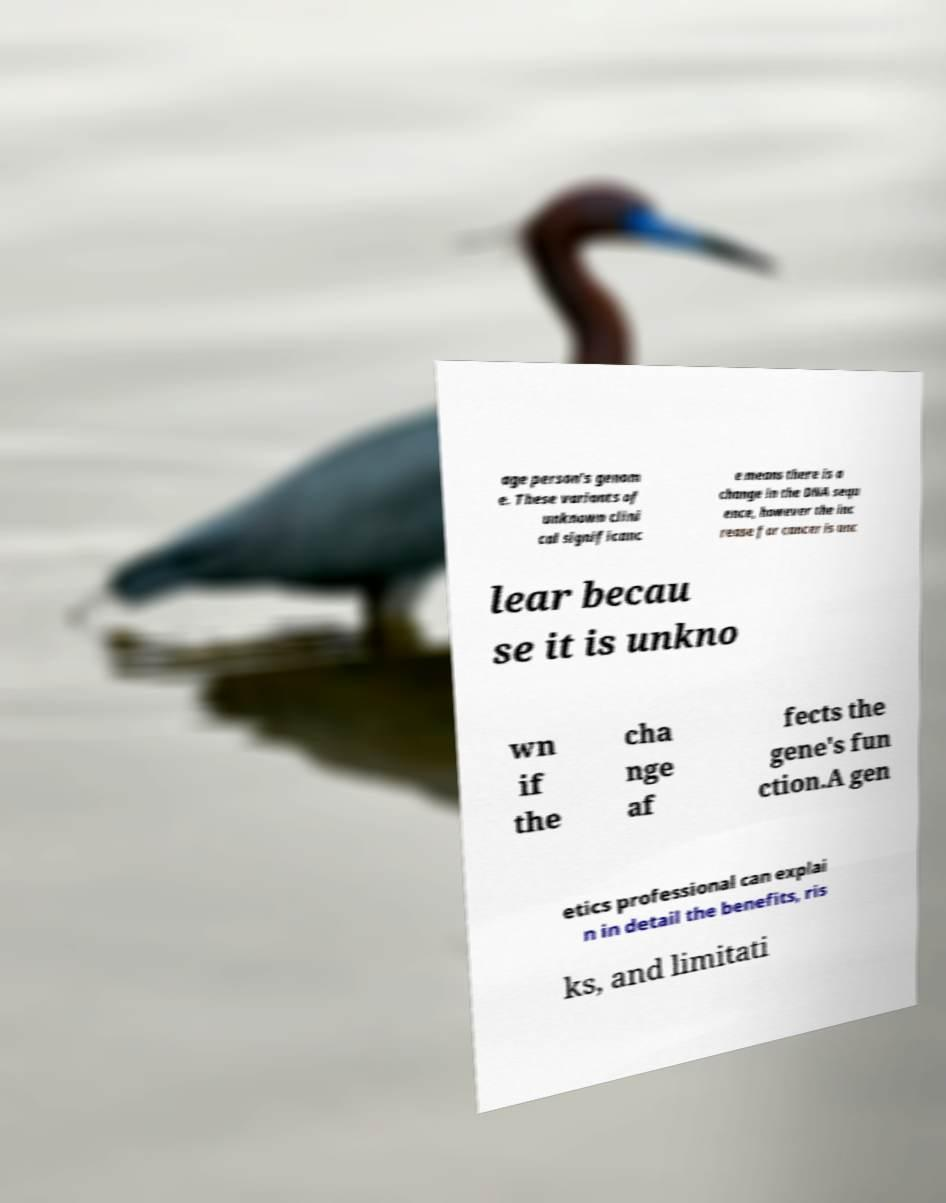Can you read and provide the text displayed in the image?This photo seems to have some interesting text. Can you extract and type it out for me? age person's genom e. These variants of unknown clini cal significanc e means there is a change in the DNA sequ ence, however the inc rease for cancer is unc lear becau se it is unkno wn if the cha nge af fects the gene's fun ction.A gen etics professional can explai n in detail the benefits, ris ks, and limitati 